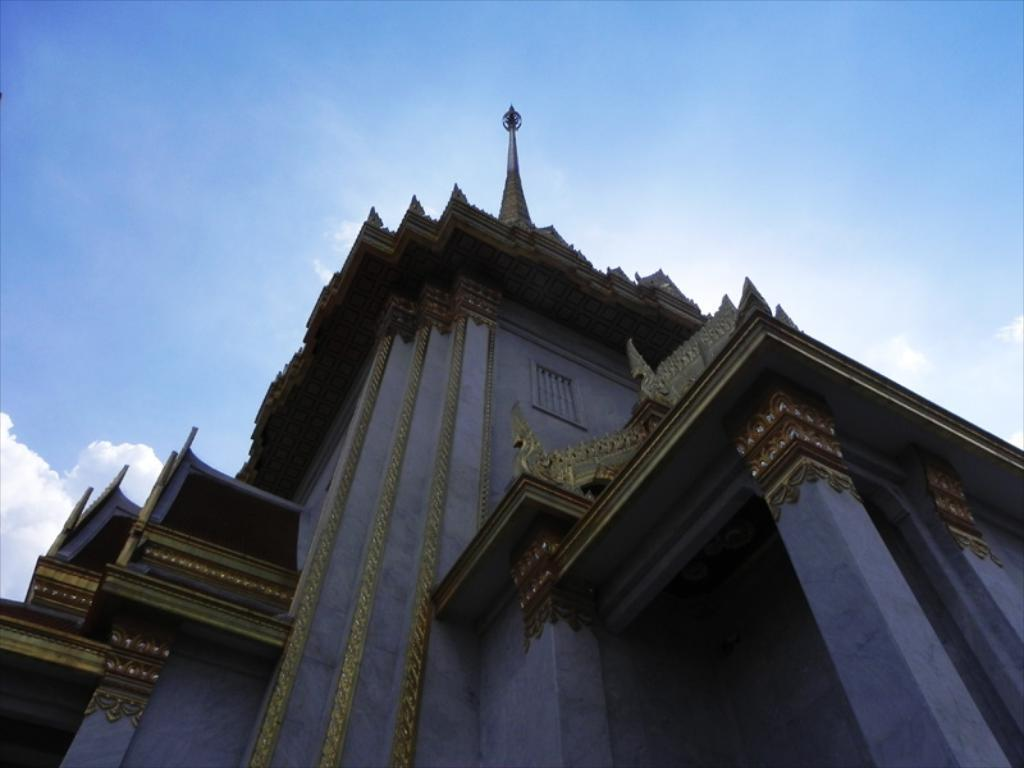What is the main structure in the center of the image? There is a building in the center of the image. What architectural features can be seen on the building? There are pillars and a tower on the building. What is visible at the top of the image? The sky is visible at the top of the image. What type of bean is growing on the building in the image? There are no beans present in the image; it features a building with pillars and a tower. 